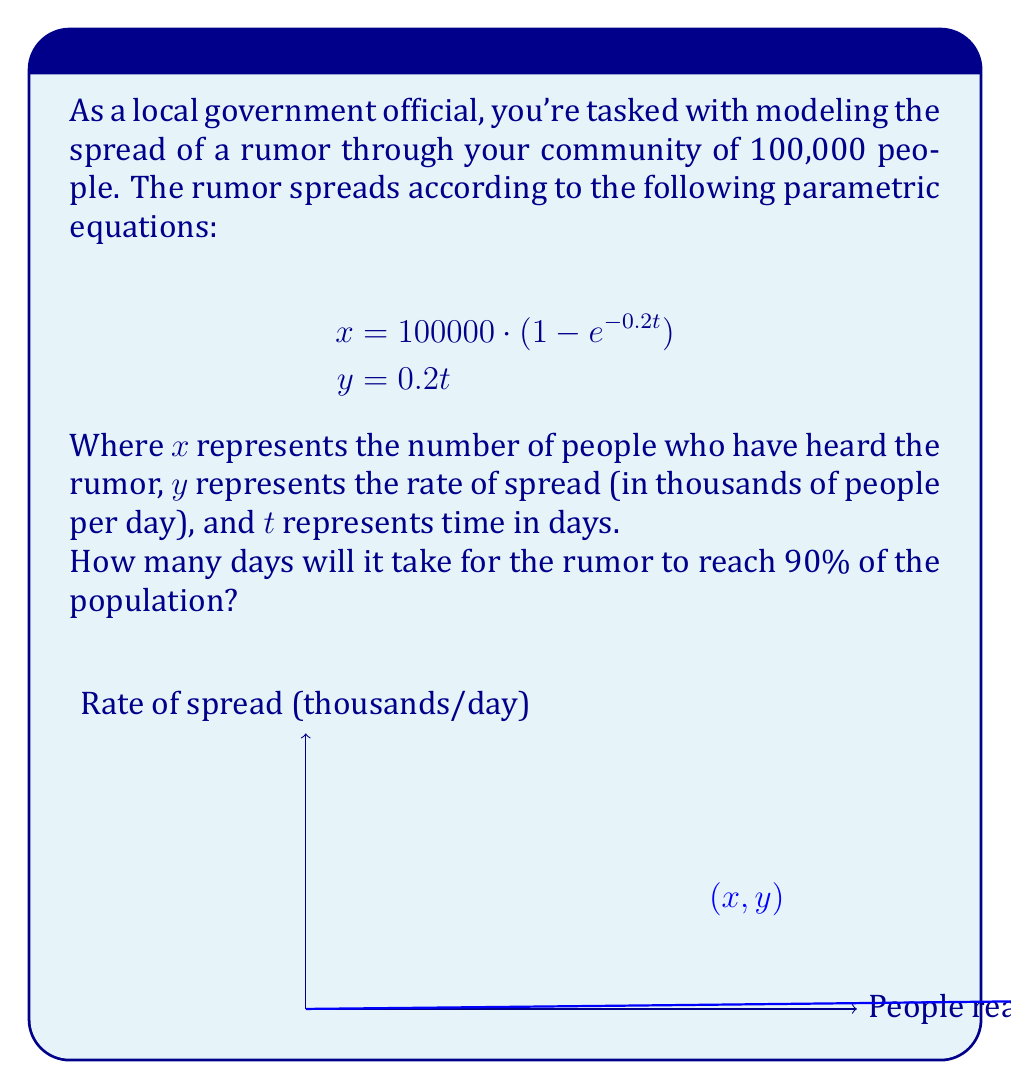Can you solve this math problem? To solve this problem, we need to follow these steps:

1) We want to find when 90% of the population has heard the rumor. That's 90% of 100,000 people, which is 90,000 people.

2) We can use the equation for $x$ to find when it equals 90,000:

   $$90000 = 100000 \cdot (1 - e^{-0.2t})$$

3) Divide both sides by 100,000:

   $$0.9 = 1 - e^{-0.2t}$$

4) Subtract both sides from 1:

   $$0.1 = e^{-0.2t}$$

5) Take the natural log of both sides:

   $$\ln(0.1) = -0.2t$$

6) Divide both sides by -0.2:

   $$\frac{\ln(0.1)}{-0.2} = t$$

7) Calculate the result:

   $$t \approx 11.51$$

8) Since we're dealing with whole days, we round up to 12 days.
Answer: 12 days 